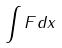<formula> <loc_0><loc_0><loc_500><loc_500>\int F d x</formula> 